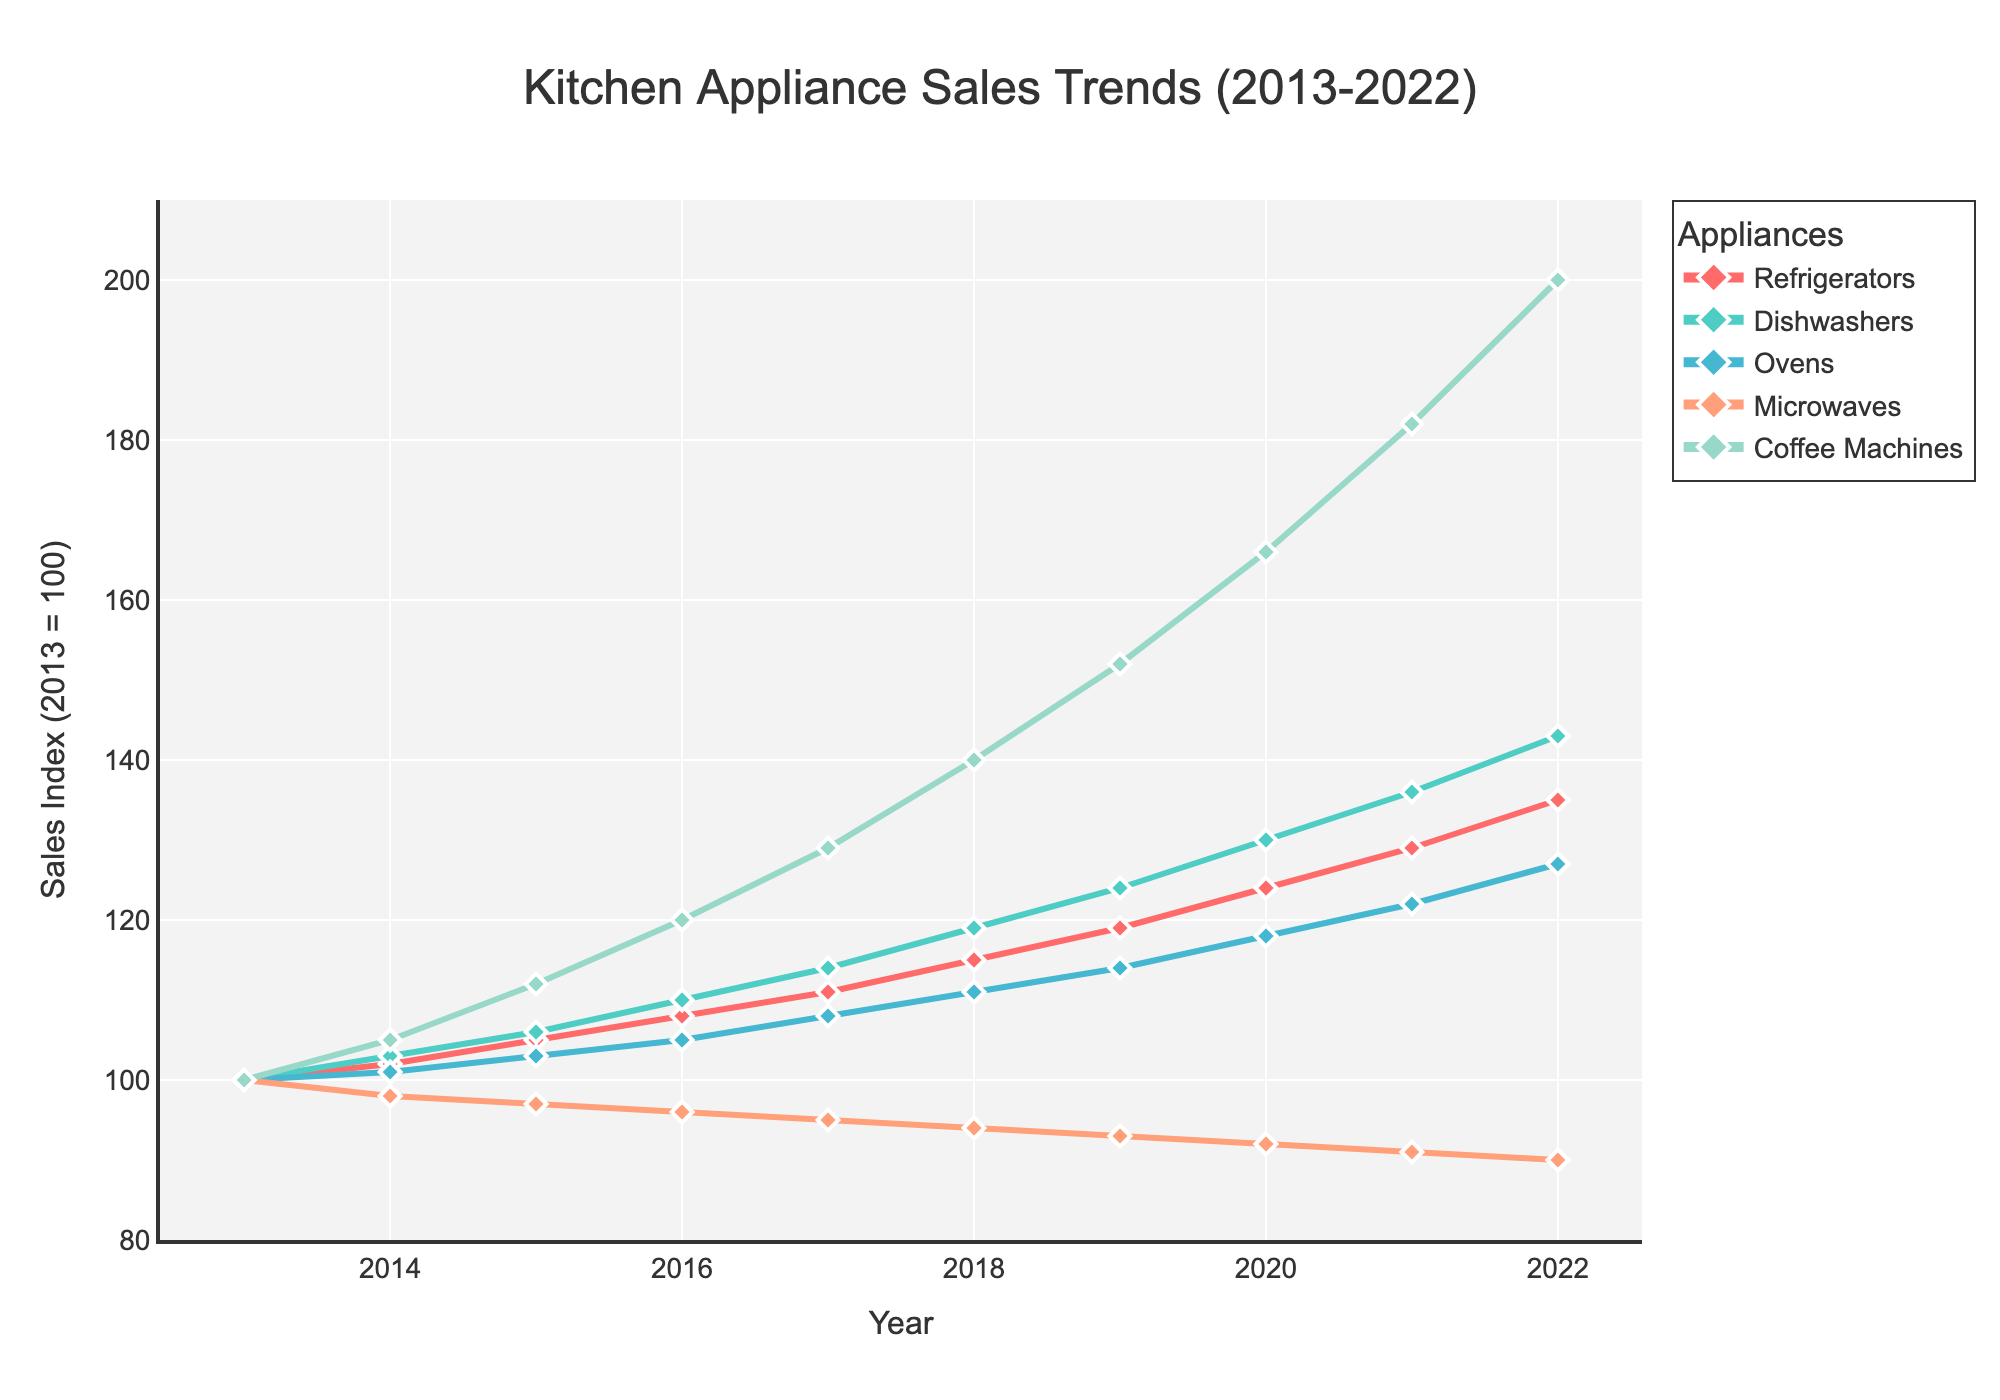What's the trend for refrigerator sales over the decade? The refrigerator sales showed a consistent increase every year from 2013 to 2022. Starting from an index of 100 in 2013, they reached 135 by 2022. The trend line for refrigerators is steadily upwards without any drops.
Answer: Steadily increasing Which kitchen appliance had the fastest growth in sales index from 2013 to 2022? By inspecting the final values for each appliance in 2022 and comparing them to their initial values in 2013, coffee machines have the highest sales index of 200 in 2022, starting from an index of 100 in 2013. This is the largest increase among all appliances.
Answer: Coffee machines How did dishwasher sales perform relative to oven sales by 2022? In 2022, the sales index for dishwashers reached 143, whereas for ovens, it reached 127. This shows that dishwashers saw a higher increase in sales index compared to ovens by 2022.
Answer: Dishwashers grew more Compare the sales index change from 2021 to 2022 for microwaves and coffee machines. From 2021 to 2022, microwaves’ sales index decreased from 91 to 90 (a decrease of 1), whereas coffee machines grew from 182 to 200 (an increase of 18).
Answer: Coffee machines increased, microwaves decreased What was the average sales index for dishwashers over the decade? To find the average sales index, add all the yearly sales indices for dishwashers and divide by the number of years. (100+103+106+110+114+119+124+130+136+143)/10 equals 120.5.
Answer: 120.5 In which years did ovens see a decrement in their sales index? By following the trend line for ovens, it shows decrement in two consecutive years: from 100 in 2013 down to 97 in 2015, and then again from 2014 to 2015 where it drops from 101 to 97.
Answer: 2014-2015 What is the difference in the sales index of refrigerators and dishwashers in the year 2019? In 2019, the sales index for refrigerators was 119 and for dishwashers was 124. The difference is 124 - 119 = 5.
Answer: 5 How did the trend for microwaves differ visually from that of other appliances? Unlike most other appliances which show a steady or increasing trend, the sales index for microwaves decreased consistently each year from 100 in 2013 to 90 in 2022.
Answer: Consistently decreasing Which appliance had the least volatile sales trend across the decade? The sales trends for refrigerators show a smooth and steady increase without any sharp increases or declines, making it the least volatile compared to others.
Answer: Refrigerators What was the combined sales index for all appliances in 2020? Adding the sales indices for all appliances in 2020: 124 (refrigerators) + 130 (dishwashers) + 118 (ovens) + 92 (microwaves) + 166 (coffee machines) equals 630.
Answer: 630 